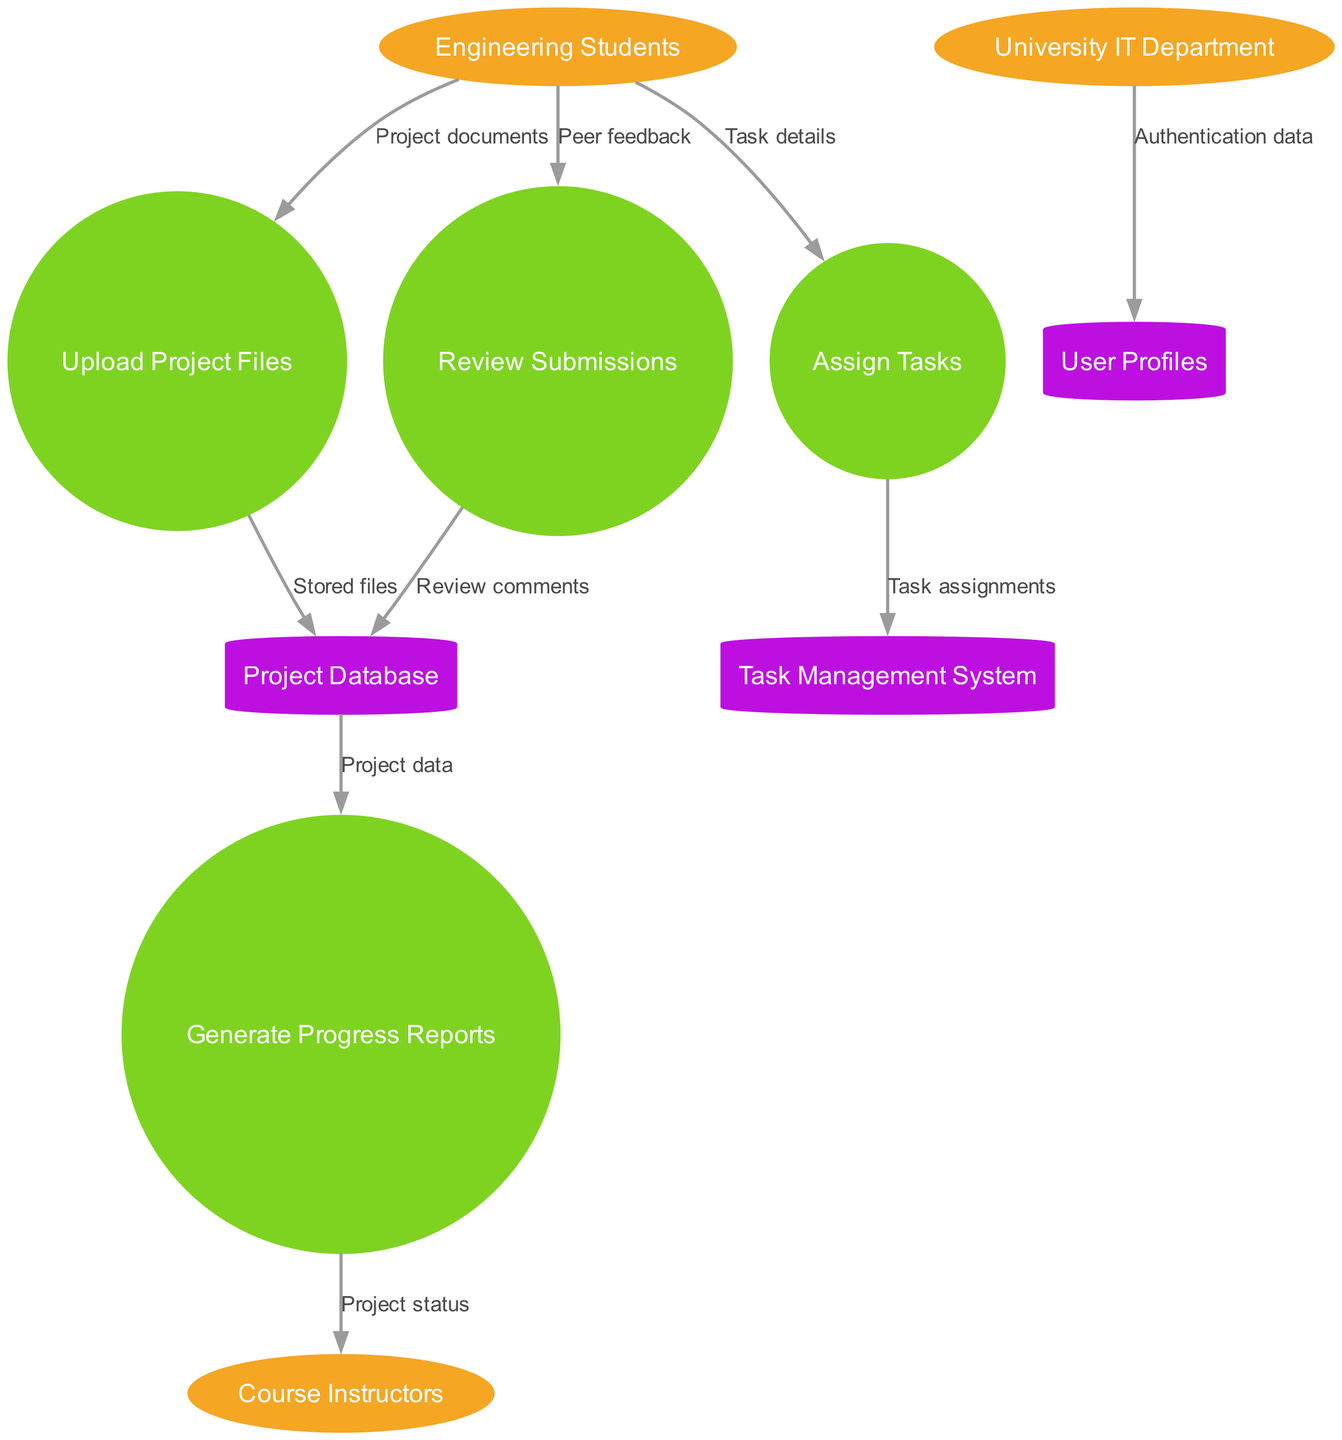What are the external entities in the diagram? There are three external entities listed in the diagram: Engineering Students, Course Instructors, and University IT Department. This information can be found under the section designated for external entities.
Answer: Engineering Students, Course Instructors, University IT Department How many processes are represented in the diagram? The diagram contains four processes: Upload Project Files, Assign Tasks, Review Submissions, and Generate Progress Reports. Counting these processes can be done by listing them in the corresponding section of the diagram.
Answer: 4 What data flows from Engineering Students to the Review Submissions process? The data flowing from Engineering Students to the Review Submissions process is labeled "Peer feedback." This can be identified by tracing the connection between these two nodes in the diagram.
Answer: Peer feedback Which data store receives "Stored files"? The "Stored files" data flows into the Project Database. This can be determined by locating the flow from Upload Project Files to Project Database and identifying the label associated with it.
Answer: Project Database What is the final output of the Generate Progress Reports process? The Generate Progress Reports process outputs "Project status" to Course Instructors. This conclusion can be reached by following the flow from Generate Progress Reports to Course Instructors in the diagram.
Answer: Project status Which external entity provides authentication data? The University IT Department provides the authentication data, as indicated by the direct flow from this external entity to the User Profiles data store. This relationship can be confirmed by analyzing the connections in the diagram.
Answer: University IT Department Which process is responsible for task assignments? The Assign Tasks process is responsible for task assignments, as shown by the direct flow into the Task Management System labeled "Task assignments." This can be observed by examining the flow between these two components.
Answer: Assign Tasks How many data stores are depicted in the diagram? There are three data stores: Project Database, User Profiles, and Task Management System. This can be confirmed by counting the distinct stores listed in the data store section of the diagram.
Answer: 3 